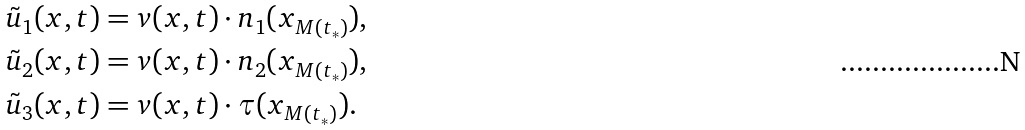<formula> <loc_0><loc_0><loc_500><loc_500>\tilde { u } _ { 1 } ( x , t ) & = v ( x , t ) \cdot n _ { 1 } ( x _ { M ( t _ { * } ) } ) , \\ \tilde { u } _ { 2 } ( x , t ) & = v ( x , t ) \cdot n _ { 2 } ( x _ { M ( t _ { * } ) } ) , \\ \tilde { u } _ { 3 } ( x , t ) & = v ( x , t ) \cdot \tau ( x _ { M ( t _ { * } ) } ) .</formula> 